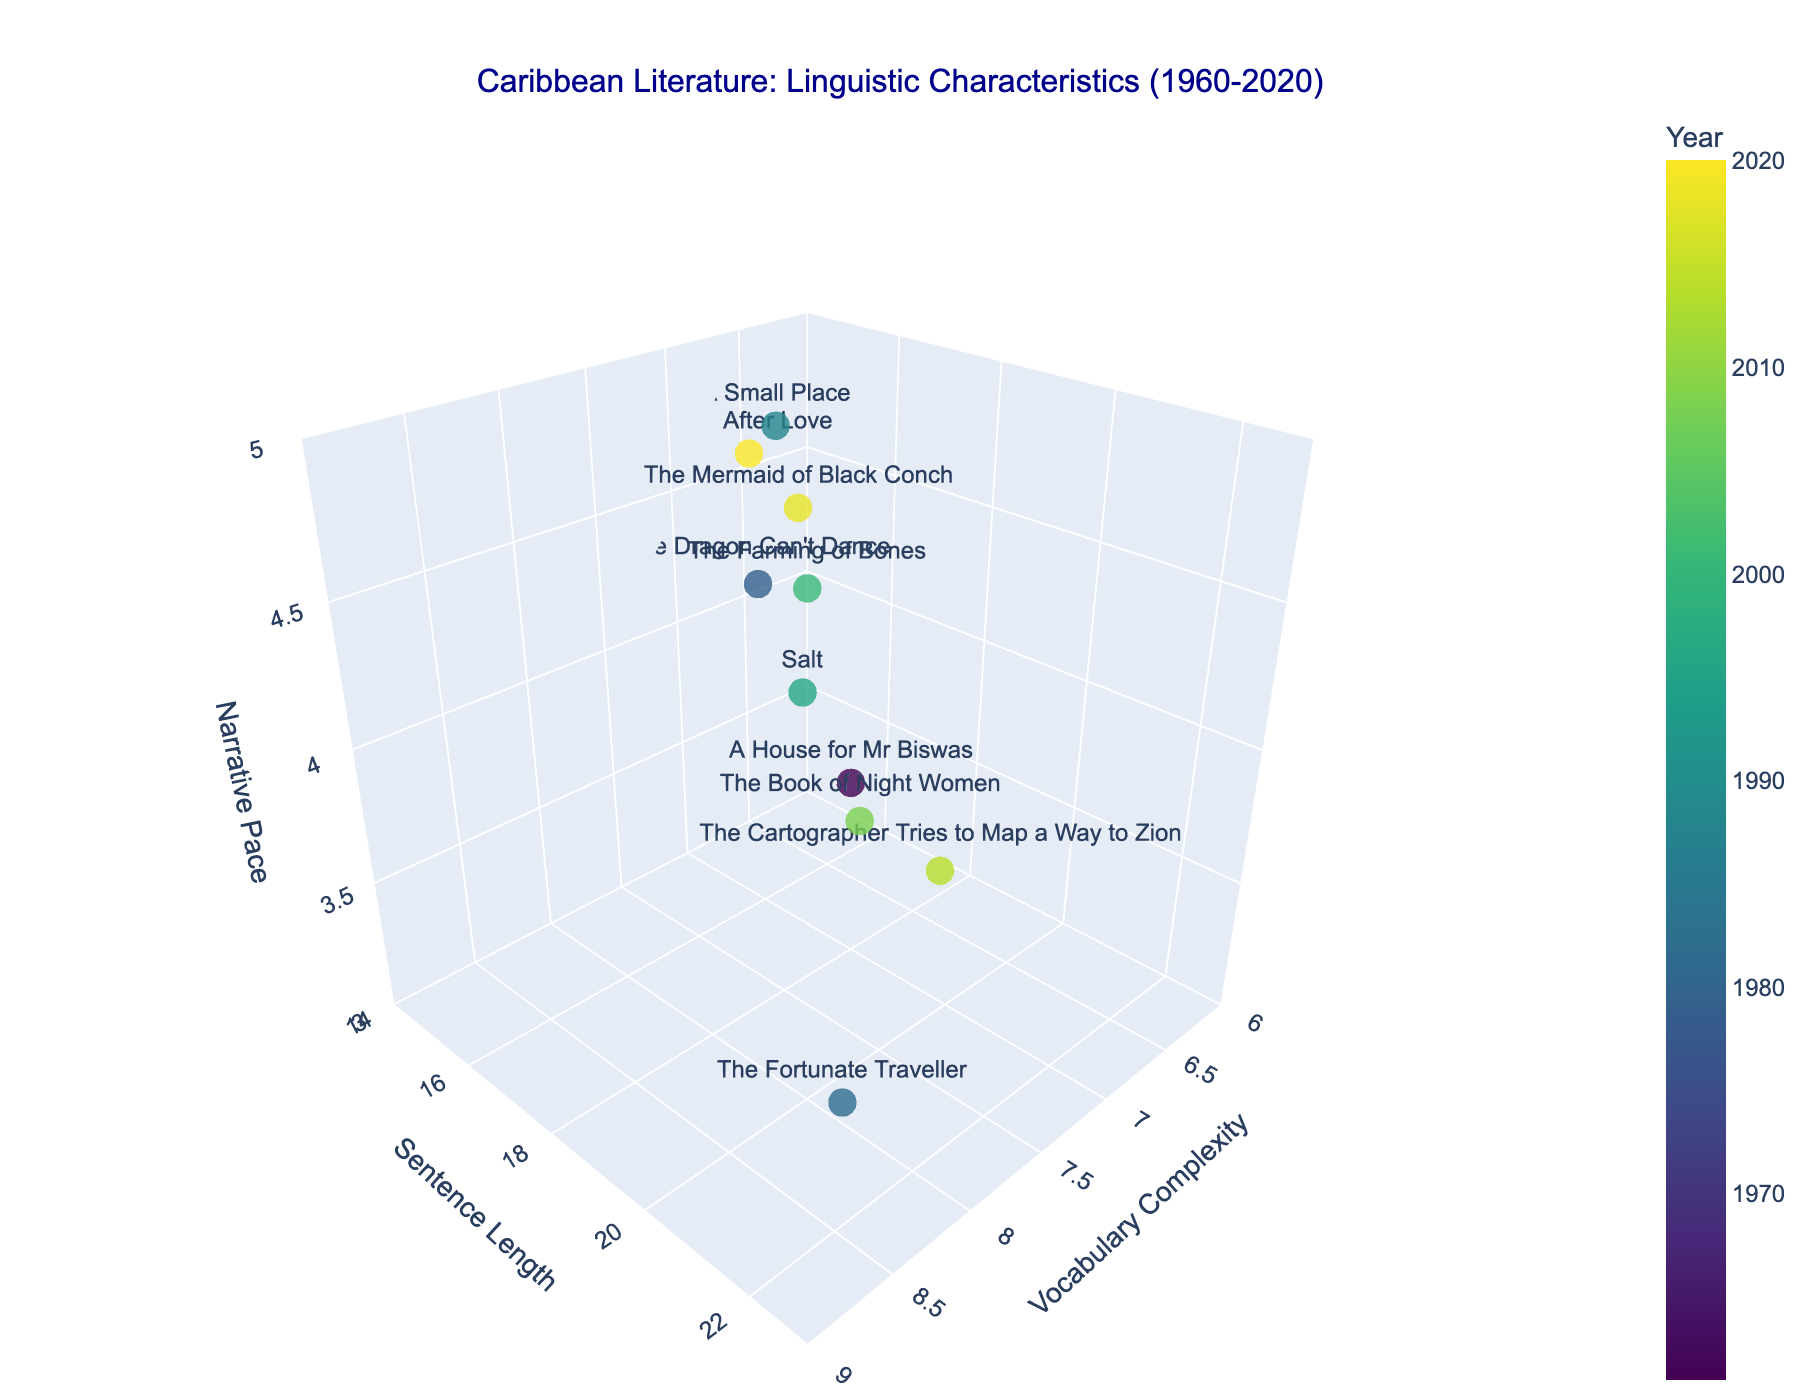How many books are represented in the figure? Count the number of unique titles visible on the plot.
Answer: 10 What range does the Vocabulary Complexity axis cover? The plot's x-axis label indicates Vocabulary Complexity. The range can be identified using the axis ticks.
Answer: 6 to 9 Which book has the highest Narrative Pace? Look for the point with the highest z-value and identify the corresponding book from its hover text or label.
Answer: A Small Place Which author appears more than once in the plot? Check the text or hover information for repeated author names.
Answer: Earl Lovelace What is the Narrative Pace of "Salt"? Find the point labeled "Salt" and check its z-axis value.
Answer: 4.0 Which book has the longest Sentence Length? Find the point with the highest y-value and identify the corresponding book.
Answer: The Fortunate Traveller Which two books have the closest Vocabulary Complexity scores? Compare the x-values of all points and identify the two with the smallest difference.
Answer: Salt and Love After Love What is the average Sentence Length of all books in the 2000s? Identify books from 2001, 2008, 2014, and 2020, sum their Sentence Length values, and divide by the number of these books. Calculation: (16.7 + 19.8 + 20.5 + 14.5) / 4 = 17.875
Answer: 17.875 